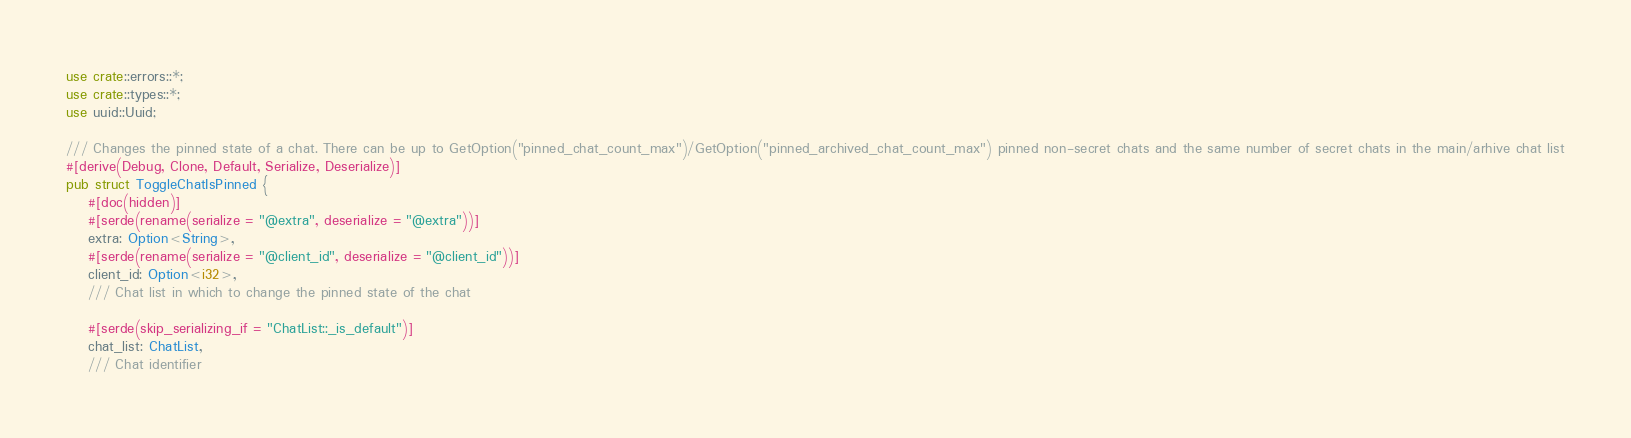Convert code to text. <code><loc_0><loc_0><loc_500><loc_500><_Rust_>use crate::errors::*;
use crate::types::*;
use uuid::Uuid;

/// Changes the pinned state of a chat. There can be up to GetOption("pinned_chat_count_max")/GetOption("pinned_archived_chat_count_max") pinned non-secret chats and the same number of secret chats in the main/arhive chat list
#[derive(Debug, Clone, Default, Serialize, Deserialize)]
pub struct ToggleChatIsPinned {
    #[doc(hidden)]
    #[serde(rename(serialize = "@extra", deserialize = "@extra"))]
    extra: Option<String>,
    #[serde(rename(serialize = "@client_id", deserialize = "@client_id"))]
    client_id: Option<i32>,
    /// Chat list in which to change the pinned state of the chat

    #[serde(skip_serializing_if = "ChatList::_is_default")]
    chat_list: ChatList,
    /// Chat identifier</code> 